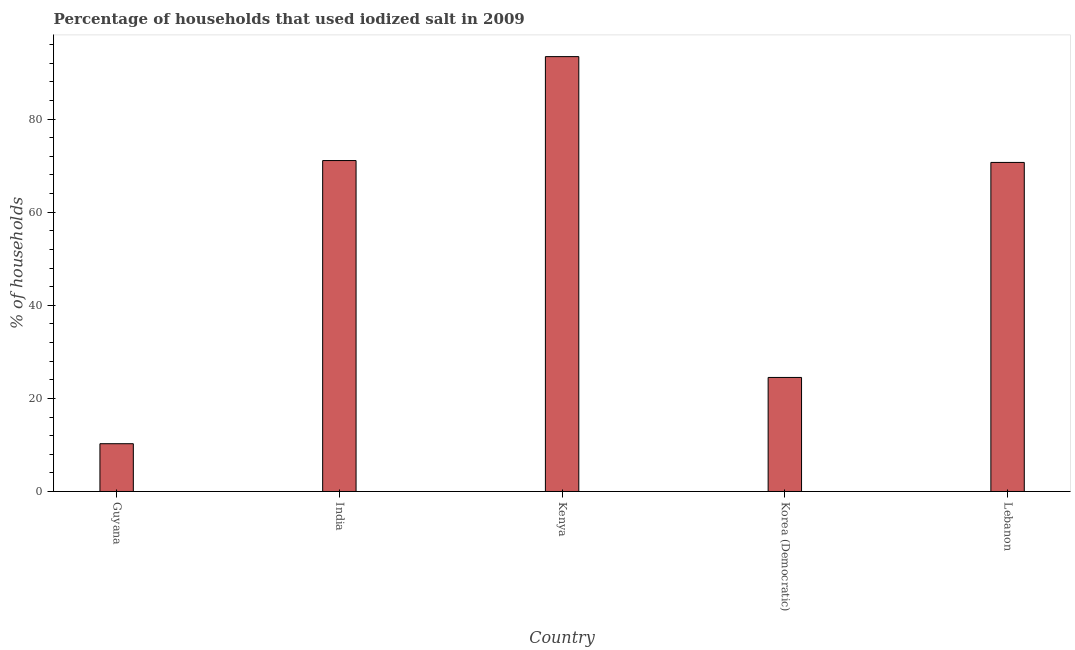Does the graph contain grids?
Your answer should be compact. No. What is the title of the graph?
Give a very brief answer. Percentage of households that used iodized salt in 2009. What is the label or title of the X-axis?
Your response must be concise. Country. What is the label or title of the Y-axis?
Ensure brevity in your answer.  % of households. Across all countries, what is the maximum percentage of households where iodized salt is consumed?
Your response must be concise. 93.43. Across all countries, what is the minimum percentage of households where iodized salt is consumed?
Ensure brevity in your answer.  10.26. In which country was the percentage of households where iodized salt is consumed maximum?
Give a very brief answer. Kenya. In which country was the percentage of households where iodized salt is consumed minimum?
Keep it short and to the point. Guyana. What is the sum of the percentage of households where iodized salt is consumed?
Make the answer very short. 269.99. What is the difference between the percentage of households where iodized salt is consumed in Kenya and Lebanon?
Your answer should be compact. 22.73. What is the average percentage of households where iodized salt is consumed per country?
Make the answer very short. 54. What is the median percentage of households where iodized salt is consumed?
Ensure brevity in your answer.  70.7. What is the ratio of the percentage of households where iodized salt is consumed in Guyana to that in Kenya?
Ensure brevity in your answer.  0.11. Is the percentage of households where iodized salt is consumed in Kenya less than that in Lebanon?
Make the answer very short. No. Is the difference between the percentage of households where iodized salt is consumed in Kenya and Korea (Democratic) greater than the difference between any two countries?
Ensure brevity in your answer.  No. What is the difference between the highest and the second highest percentage of households where iodized salt is consumed?
Ensure brevity in your answer.  22.33. What is the difference between the highest and the lowest percentage of households where iodized salt is consumed?
Offer a very short reply. 83.17. In how many countries, is the percentage of households where iodized salt is consumed greater than the average percentage of households where iodized salt is consumed taken over all countries?
Your response must be concise. 3. How many countries are there in the graph?
Offer a very short reply. 5. What is the difference between two consecutive major ticks on the Y-axis?
Your response must be concise. 20. What is the % of households of Guyana?
Your response must be concise. 10.26. What is the % of households in India?
Offer a very short reply. 71.1. What is the % of households in Kenya?
Provide a succinct answer. 93.43. What is the % of households of Lebanon?
Provide a succinct answer. 70.7. What is the difference between the % of households in Guyana and India?
Offer a terse response. -60.84. What is the difference between the % of households in Guyana and Kenya?
Provide a succinct answer. -83.17. What is the difference between the % of households in Guyana and Korea (Democratic)?
Your response must be concise. -14.24. What is the difference between the % of households in Guyana and Lebanon?
Offer a terse response. -60.44. What is the difference between the % of households in India and Kenya?
Keep it short and to the point. -22.33. What is the difference between the % of households in India and Korea (Democratic)?
Make the answer very short. 46.6. What is the difference between the % of households in India and Lebanon?
Ensure brevity in your answer.  0.4. What is the difference between the % of households in Kenya and Korea (Democratic)?
Ensure brevity in your answer.  68.93. What is the difference between the % of households in Kenya and Lebanon?
Make the answer very short. 22.73. What is the difference between the % of households in Korea (Democratic) and Lebanon?
Offer a terse response. -46.2. What is the ratio of the % of households in Guyana to that in India?
Your answer should be very brief. 0.14. What is the ratio of the % of households in Guyana to that in Kenya?
Your response must be concise. 0.11. What is the ratio of the % of households in Guyana to that in Korea (Democratic)?
Make the answer very short. 0.42. What is the ratio of the % of households in Guyana to that in Lebanon?
Your answer should be compact. 0.14. What is the ratio of the % of households in India to that in Kenya?
Your answer should be compact. 0.76. What is the ratio of the % of households in India to that in Korea (Democratic)?
Offer a terse response. 2.9. What is the ratio of the % of households in India to that in Lebanon?
Your response must be concise. 1.01. What is the ratio of the % of households in Kenya to that in Korea (Democratic)?
Your response must be concise. 3.81. What is the ratio of the % of households in Kenya to that in Lebanon?
Ensure brevity in your answer.  1.32. What is the ratio of the % of households in Korea (Democratic) to that in Lebanon?
Offer a very short reply. 0.35. 